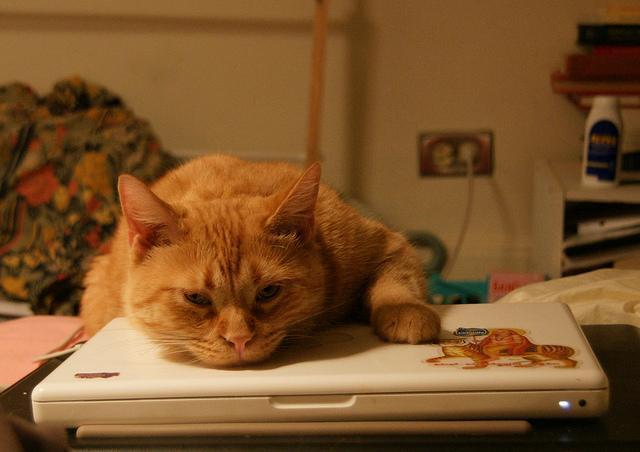How many people are wearing black pants?
Give a very brief answer. 0. 